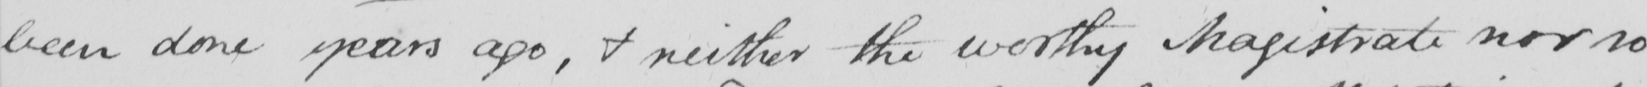Can you tell me what this handwritten text says? been done years ago , & neither the worthy Magistrate nor so 